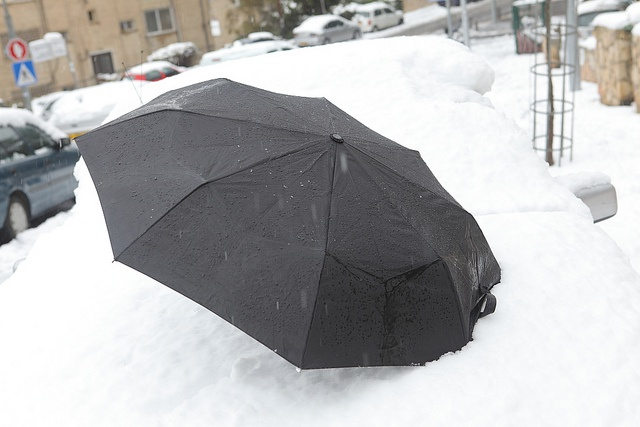Describe the objects in this image and their specific colors. I can see umbrella in tan, gray, black, and darkgray tones, car in tan, gray, darkgray, and black tones, car in tan, white, darkgray, and lightgray tones, car in tan, darkgray, lightgray, and gray tones, and car in tan, darkgray, lightgray, and gray tones in this image. 